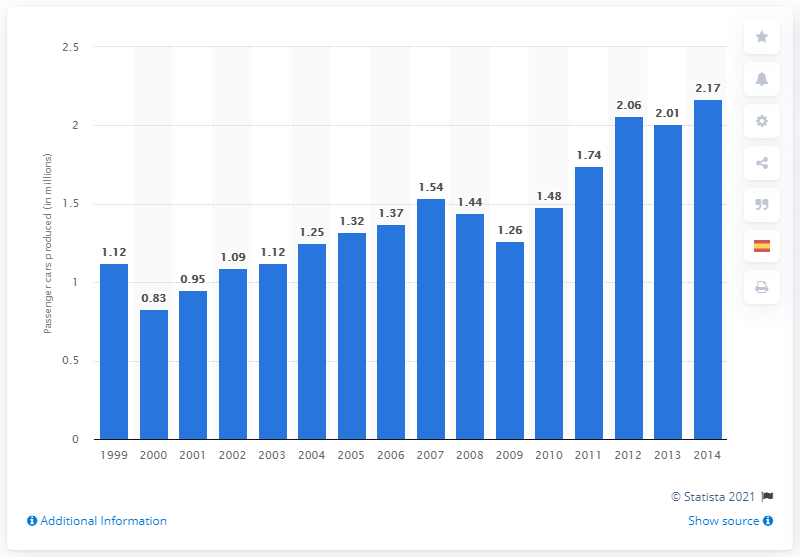Point out several critical features in this image. In 2014, BMW produced a total of 2,170 passenger cars. 